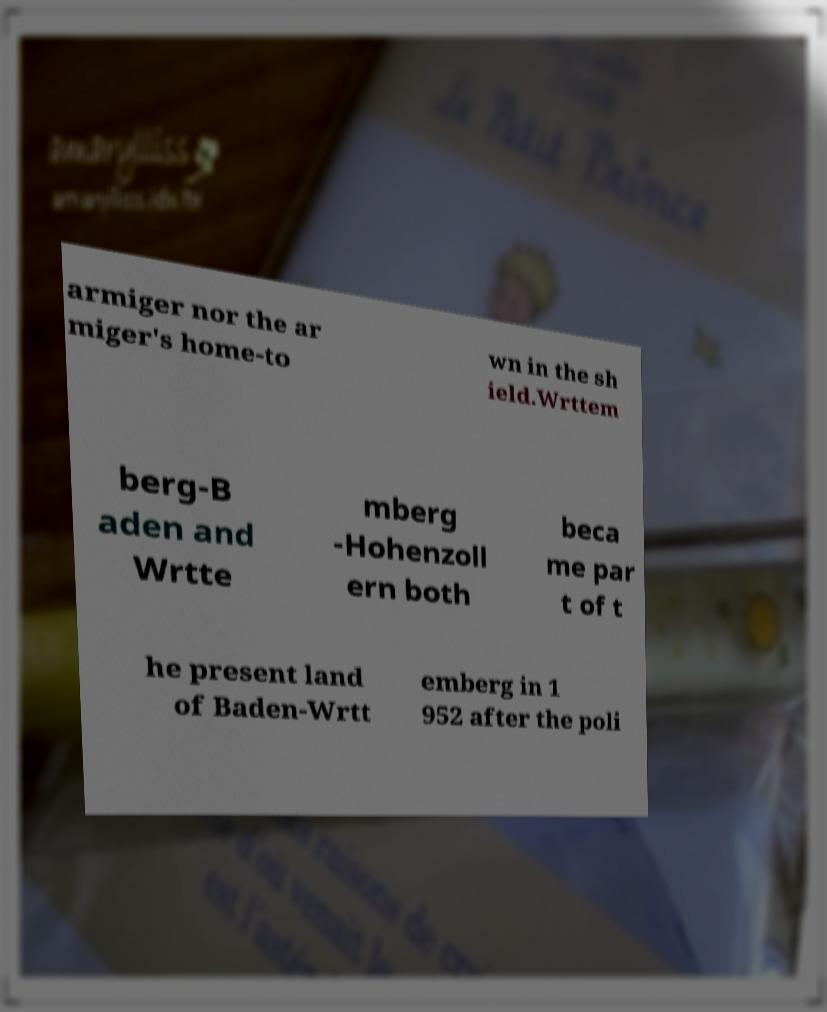What messages or text are displayed in this image? I need them in a readable, typed format. armiger nor the ar miger's home-to wn in the sh ield.Wrttem berg-B aden and Wrtte mberg -Hohenzoll ern both beca me par t of t he present land of Baden-Wrtt emberg in 1 952 after the poli 